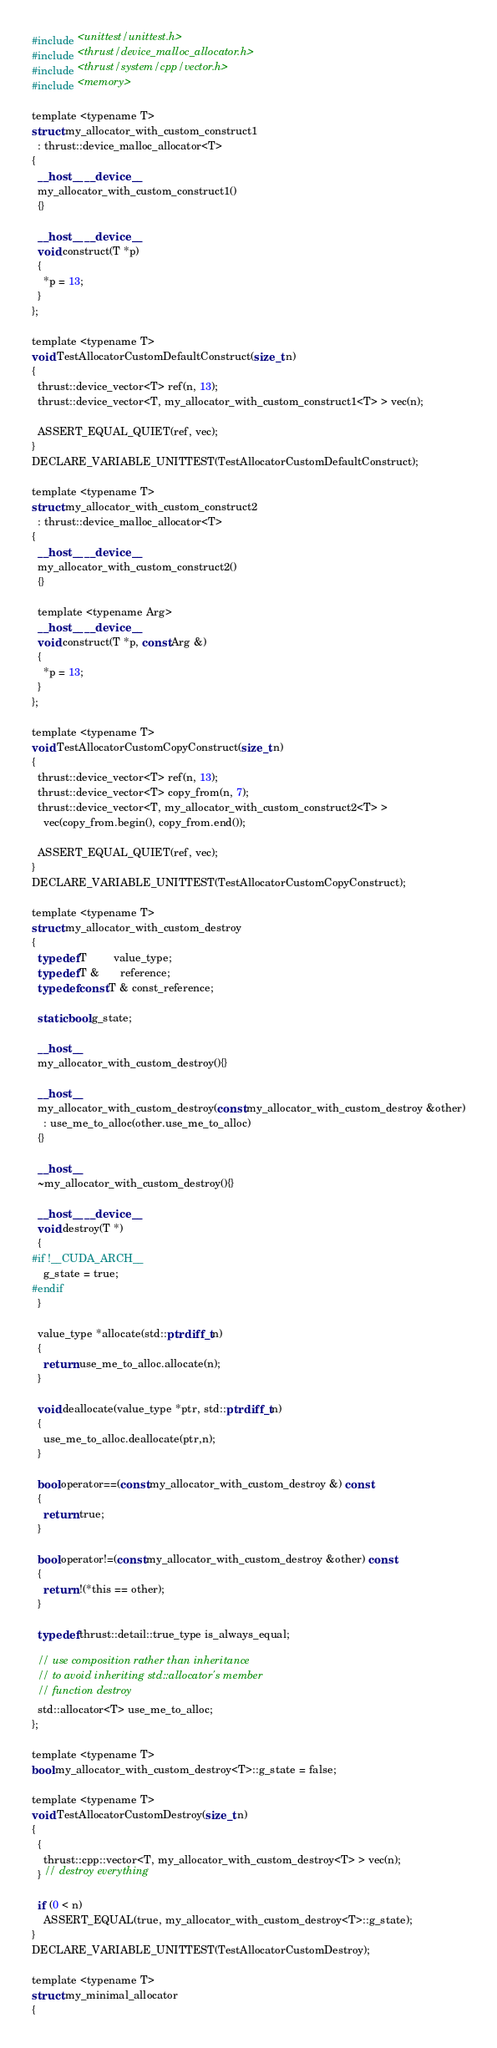<code> <loc_0><loc_0><loc_500><loc_500><_Cuda_>#include <unittest/unittest.h>
#include <thrust/device_malloc_allocator.h>
#include <thrust/system/cpp/vector.h>
#include <memory>

template <typename T>
struct my_allocator_with_custom_construct1
  : thrust::device_malloc_allocator<T>
{
  __host__ __device__
  my_allocator_with_custom_construct1()
  {}

  __host__ __device__
  void construct(T *p)
  {
    *p = 13;
  }
};

template <typename T>
void TestAllocatorCustomDefaultConstruct(size_t n)
{
  thrust::device_vector<T> ref(n, 13);
  thrust::device_vector<T, my_allocator_with_custom_construct1<T> > vec(n);

  ASSERT_EQUAL_QUIET(ref, vec);
}
DECLARE_VARIABLE_UNITTEST(TestAllocatorCustomDefaultConstruct);

template <typename T>
struct my_allocator_with_custom_construct2
  : thrust::device_malloc_allocator<T>
{
  __host__ __device__
  my_allocator_with_custom_construct2()
  {}

  template <typename Arg>
  __host__ __device__
  void construct(T *p, const Arg &)
  {
    *p = 13;
  }
};

template <typename T>
void TestAllocatorCustomCopyConstruct(size_t n)
{
  thrust::device_vector<T> ref(n, 13);
  thrust::device_vector<T> copy_from(n, 7);
  thrust::device_vector<T, my_allocator_with_custom_construct2<T> >
    vec(copy_from.begin(), copy_from.end());

  ASSERT_EQUAL_QUIET(ref, vec);
}
DECLARE_VARIABLE_UNITTEST(TestAllocatorCustomCopyConstruct);

template <typename T>
struct my_allocator_with_custom_destroy
{
  typedef T         value_type;
  typedef T &       reference;
  typedef const T & const_reference;

  static bool g_state;

  __host__
  my_allocator_with_custom_destroy(){}

  __host__
  my_allocator_with_custom_destroy(const my_allocator_with_custom_destroy &other)
    : use_me_to_alloc(other.use_me_to_alloc)
  {}

  __host__
  ~my_allocator_with_custom_destroy(){}

  __host__ __device__
  void destroy(T *)
  {
#if !__CUDA_ARCH__
    g_state = true;
#endif
  }

  value_type *allocate(std::ptrdiff_t n)
  {
    return use_me_to_alloc.allocate(n);
  }

  void deallocate(value_type *ptr, std::ptrdiff_t n)
  {
    use_me_to_alloc.deallocate(ptr,n);
  }

  bool operator==(const my_allocator_with_custom_destroy &) const
  {
    return true;
  }

  bool operator!=(const my_allocator_with_custom_destroy &other) const
  {
    return !(*this == other);
  }

  typedef thrust::detail::true_type is_always_equal;

  // use composition rather than inheritance
  // to avoid inheriting std::allocator's member
  // function destroy
  std::allocator<T> use_me_to_alloc;
};

template <typename T>
bool my_allocator_with_custom_destroy<T>::g_state = false;

template <typename T>
void TestAllocatorCustomDestroy(size_t n)
{
  {
    thrust::cpp::vector<T, my_allocator_with_custom_destroy<T> > vec(n);
  } // destroy everything

  if (0 < n)
    ASSERT_EQUAL(true, my_allocator_with_custom_destroy<T>::g_state);
}
DECLARE_VARIABLE_UNITTEST(TestAllocatorCustomDestroy);

template <typename T>
struct my_minimal_allocator
{</code> 